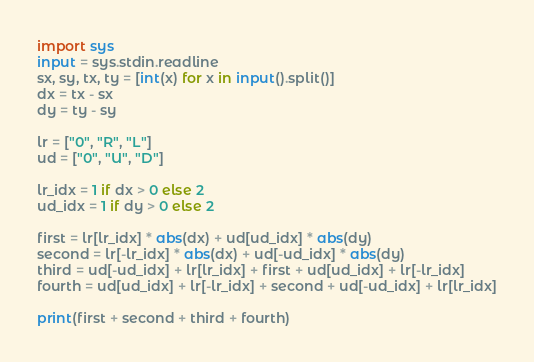Convert code to text. <code><loc_0><loc_0><loc_500><loc_500><_Python_>import sys
input = sys.stdin.readline
sx, sy, tx, ty = [int(x) for x in input().split()]
dx = tx - sx
dy = ty - sy

lr = ["0", "R", "L"]
ud = ["0", "U", "D"]

lr_idx = 1 if dx > 0 else 2
ud_idx = 1 if dy > 0 else 2

first = lr[lr_idx] * abs(dx) + ud[ud_idx] * abs(dy)
second = lr[-lr_idx] * abs(dx) + ud[-ud_idx] * abs(dy)
third = ud[-ud_idx] + lr[lr_idx] + first + ud[ud_idx] + lr[-lr_idx]
fourth = ud[ud_idx] + lr[-lr_idx] + second + ud[-ud_idx] + lr[lr_idx]

print(first + second + third + fourth)</code> 